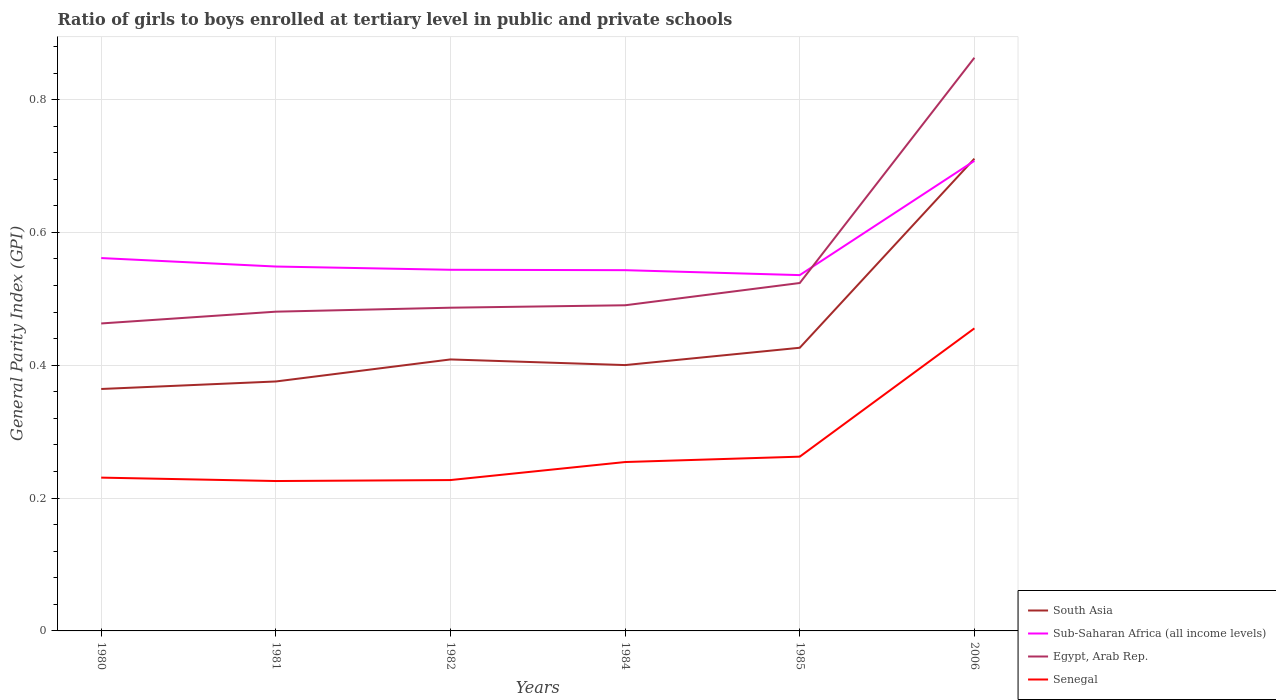Across all years, what is the maximum general parity index in Senegal?
Offer a very short reply. 0.23. In which year was the general parity index in Sub-Saharan Africa (all income levels) maximum?
Provide a succinct answer. 1985. What is the total general parity index in Egypt, Arab Rep. in the graph?
Ensure brevity in your answer.  -0.03. What is the difference between the highest and the second highest general parity index in Egypt, Arab Rep.?
Your answer should be very brief. 0.4. What is the difference between the highest and the lowest general parity index in South Asia?
Ensure brevity in your answer.  1. How many lines are there?
Provide a succinct answer. 4. How many years are there in the graph?
Your answer should be very brief. 6. Does the graph contain any zero values?
Ensure brevity in your answer.  No. Where does the legend appear in the graph?
Your response must be concise. Bottom right. How are the legend labels stacked?
Offer a terse response. Vertical. What is the title of the graph?
Make the answer very short. Ratio of girls to boys enrolled at tertiary level in public and private schools. Does "Vanuatu" appear as one of the legend labels in the graph?
Make the answer very short. No. What is the label or title of the X-axis?
Your response must be concise. Years. What is the label or title of the Y-axis?
Provide a succinct answer. General Parity Index (GPI). What is the General Parity Index (GPI) of South Asia in 1980?
Ensure brevity in your answer.  0.36. What is the General Parity Index (GPI) of Sub-Saharan Africa (all income levels) in 1980?
Offer a terse response. 0.56. What is the General Parity Index (GPI) in Egypt, Arab Rep. in 1980?
Provide a short and direct response. 0.46. What is the General Parity Index (GPI) in Senegal in 1980?
Your answer should be very brief. 0.23. What is the General Parity Index (GPI) in South Asia in 1981?
Make the answer very short. 0.38. What is the General Parity Index (GPI) of Sub-Saharan Africa (all income levels) in 1981?
Keep it short and to the point. 0.55. What is the General Parity Index (GPI) in Egypt, Arab Rep. in 1981?
Provide a short and direct response. 0.48. What is the General Parity Index (GPI) of Senegal in 1981?
Provide a succinct answer. 0.23. What is the General Parity Index (GPI) in South Asia in 1982?
Give a very brief answer. 0.41. What is the General Parity Index (GPI) of Sub-Saharan Africa (all income levels) in 1982?
Ensure brevity in your answer.  0.54. What is the General Parity Index (GPI) of Egypt, Arab Rep. in 1982?
Your answer should be very brief. 0.49. What is the General Parity Index (GPI) of Senegal in 1982?
Give a very brief answer. 0.23. What is the General Parity Index (GPI) of South Asia in 1984?
Make the answer very short. 0.4. What is the General Parity Index (GPI) in Sub-Saharan Africa (all income levels) in 1984?
Offer a terse response. 0.54. What is the General Parity Index (GPI) of Egypt, Arab Rep. in 1984?
Keep it short and to the point. 0.49. What is the General Parity Index (GPI) of Senegal in 1984?
Provide a short and direct response. 0.25. What is the General Parity Index (GPI) of South Asia in 1985?
Provide a short and direct response. 0.43. What is the General Parity Index (GPI) in Sub-Saharan Africa (all income levels) in 1985?
Your answer should be compact. 0.54. What is the General Parity Index (GPI) in Egypt, Arab Rep. in 1985?
Make the answer very short. 0.52. What is the General Parity Index (GPI) of Senegal in 1985?
Your answer should be compact. 0.26. What is the General Parity Index (GPI) of South Asia in 2006?
Offer a very short reply. 0.71. What is the General Parity Index (GPI) in Sub-Saharan Africa (all income levels) in 2006?
Your answer should be compact. 0.71. What is the General Parity Index (GPI) of Egypt, Arab Rep. in 2006?
Your answer should be compact. 0.86. What is the General Parity Index (GPI) of Senegal in 2006?
Offer a terse response. 0.46. Across all years, what is the maximum General Parity Index (GPI) in South Asia?
Make the answer very short. 0.71. Across all years, what is the maximum General Parity Index (GPI) of Sub-Saharan Africa (all income levels)?
Your answer should be compact. 0.71. Across all years, what is the maximum General Parity Index (GPI) in Egypt, Arab Rep.?
Provide a succinct answer. 0.86. Across all years, what is the maximum General Parity Index (GPI) in Senegal?
Your answer should be very brief. 0.46. Across all years, what is the minimum General Parity Index (GPI) in South Asia?
Keep it short and to the point. 0.36. Across all years, what is the minimum General Parity Index (GPI) of Sub-Saharan Africa (all income levels)?
Offer a very short reply. 0.54. Across all years, what is the minimum General Parity Index (GPI) of Egypt, Arab Rep.?
Provide a short and direct response. 0.46. Across all years, what is the minimum General Parity Index (GPI) of Senegal?
Make the answer very short. 0.23. What is the total General Parity Index (GPI) in South Asia in the graph?
Give a very brief answer. 2.69. What is the total General Parity Index (GPI) of Sub-Saharan Africa (all income levels) in the graph?
Your response must be concise. 3.44. What is the total General Parity Index (GPI) of Egypt, Arab Rep. in the graph?
Give a very brief answer. 3.31. What is the total General Parity Index (GPI) of Senegal in the graph?
Make the answer very short. 1.66. What is the difference between the General Parity Index (GPI) of South Asia in 1980 and that in 1981?
Your answer should be compact. -0.01. What is the difference between the General Parity Index (GPI) of Sub-Saharan Africa (all income levels) in 1980 and that in 1981?
Your answer should be compact. 0.01. What is the difference between the General Parity Index (GPI) in Egypt, Arab Rep. in 1980 and that in 1981?
Offer a very short reply. -0.02. What is the difference between the General Parity Index (GPI) of Senegal in 1980 and that in 1981?
Your answer should be very brief. 0.01. What is the difference between the General Parity Index (GPI) in South Asia in 1980 and that in 1982?
Keep it short and to the point. -0.04. What is the difference between the General Parity Index (GPI) of Sub-Saharan Africa (all income levels) in 1980 and that in 1982?
Provide a short and direct response. 0.02. What is the difference between the General Parity Index (GPI) in Egypt, Arab Rep. in 1980 and that in 1982?
Offer a terse response. -0.02. What is the difference between the General Parity Index (GPI) in Senegal in 1980 and that in 1982?
Your answer should be very brief. 0. What is the difference between the General Parity Index (GPI) in South Asia in 1980 and that in 1984?
Give a very brief answer. -0.04. What is the difference between the General Parity Index (GPI) in Sub-Saharan Africa (all income levels) in 1980 and that in 1984?
Keep it short and to the point. 0.02. What is the difference between the General Parity Index (GPI) of Egypt, Arab Rep. in 1980 and that in 1984?
Offer a very short reply. -0.03. What is the difference between the General Parity Index (GPI) of Senegal in 1980 and that in 1984?
Your answer should be compact. -0.02. What is the difference between the General Parity Index (GPI) in South Asia in 1980 and that in 1985?
Ensure brevity in your answer.  -0.06. What is the difference between the General Parity Index (GPI) in Sub-Saharan Africa (all income levels) in 1980 and that in 1985?
Offer a very short reply. 0.03. What is the difference between the General Parity Index (GPI) of Egypt, Arab Rep. in 1980 and that in 1985?
Offer a very short reply. -0.06. What is the difference between the General Parity Index (GPI) of Senegal in 1980 and that in 1985?
Offer a terse response. -0.03. What is the difference between the General Parity Index (GPI) of South Asia in 1980 and that in 2006?
Provide a succinct answer. -0.35. What is the difference between the General Parity Index (GPI) of Sub-Saharan Africa (all income levels) in 1980 and that in 2006?
Offer a terse response. -0.15. What is the difference between the General Parity Index (GPI) in Egypt, Arab Rep. in 1980 and that in 2006?
Your response must be concise. -0.4. What is the difference between the General Parity Index (GPI) in Senegal in 1980 and that in 2006?
Give a very brief answer. -0.22. What is the difference between the General Parity Index (GPI) of South Asia in 1981 and that in 1982?
Your response must be concise. -0.03. What is the difference between the General Parity Index (GPI) in Sub-Saharan Africa (all income levels) in 1981 and that in 1982?
Provide a short and direct response. 0. What is the difference between the General Parity Index (GPI) of Egypt, Arab Rep. in 1981 and that in 1982?
Offer a very short reply. -0.01. What is the difference between the General Parity Index (GPI) in Senegal in 1981 and that in 1982?
Your response must be concise. -0. What is the difference between the General Parity Index (GPI) of South Asia in 1981 and that in 1984?
Offer a very short reply. -0.02. What is the difference between the General Parity Index (GPI) of Sub-Saharan Africa (all income levels) in 1981 and that in 1984?
Keep it short and to the point. 0.01. What is the difference between the General Parity Index (GPI) of Egypt, Arab Rep. in 1981 and that in 1984?
Make the answer very short. -0.01. What is the difference between the General Parity Index (GPI) in Senegal in 1981 and that in 1984?
Offer a terse response. -0.03. What is the difference between the General Parity Index (GPI) of South Asia in 1981 and that in 1985?
Offer a very short reply. -0.05. What is the difference between the General Parity Index (GPI) in Sub-Saharan Africa (all income levels) in 1981 and that in 1985?
Make the answer very short. 0.01. What is the difference between the General Parity Index (GPI) of Egypt, Arab Rep. in 1981 and that in 1985?
Give a very brief answer. -0.04. What is the difference between the General Parity Index (GPI) of Senegal in 1981 and that in 1985?
Make the answer very short. -0.04. What is the difference between the General Parity Index (GPI) in South Asia in 1981 and that in 2006?
Your answer should be compact. -0.34. What is the difference between the General Parity Index (GPI) in Sub-Saharan Africa (all income levels) in 1981 and that in 2006?
Ensure brevity in your answer.  -0.16. What is the difference between the General Parity Index (GPI) of Egypt, Arab Rep. in 1981 and that in 2006?
Make the answer very short. -0.38. What is the difference between the General Parity Index (GPI) of Senegal in 1981 and that in 2006?
Offer a terse response. -0.23. What is the difference between the General Parity Index (GPI) in South Asia in 1982 and that in 1984?
Ensure brevity in your answer.  0.01. What is the difference between the General Parity Index (GPI) in Sub-Saharan Africa (all income levels) in 1982 and that in 1984?
Offer a terse response. 0. What is the difference between the General Parity Index (GPI) of Egypt, Arab Rep. in 1982 and that in 1984?
Provide a short and direct response. -0. What is the difference between the General Parity Index (GPI) of Senegal in 1982 and that in 1984?
Offer a very short reply. -0.03. What is the difference between the General Parity Index (GPI) of South Asia in 1982 and that in 1985?
Offer a terse response. -0.02. What is the difference between the General Parity Index (GPI) of Sub-Saharan Africa (all income levels) in 1982 and that in 1985?
Offer a very short reply. 0.01. What is the difference between the General Parity Index (GPI) of Egypt, Arab Rep. in 1982 and that in 1985?
Make the answer very short. -0.04. What is the difference between the General Parity Index (GPI) in Senegal in 1982 and that in 1985?
Offer a terse response. -0.04. What is the difference between the General Parity Index (GPI) in South Asia in 1982 and that in 2006?
Provide a succinct answer. -0.3. What is the difference between the General Parity Index (GPI) of Sub-Saharan Africa (all income levels) in 1982 and that in 2006?
Provide a short and direct response. -0.16. What is the difference between the General Parity Index (GPI) of Egypt, Arab Rep. in 1982 and that in 2006?
Your answer should be very brief. -0.38. What is the difference between the General Parity Index (GPI) in Senegal in 1982 and that in 2006?
Your response must be concise. -0.23. What is the difference between the General Parity Index (GPI) in South Asia in 1984 and that in 1985?
Make the answer very short. -0.03. What is the difference between the General Parity Index (GPI) in Sub-Saharan Africa (all income levels) in 1984 and that in 1985?
Make the answer very short. 0.01. What is the difference between the General Parity Index (GPI) of Egypt, Arab Rep. in 1984 and that in 1985?
Offer a terse response. -0.03. What is the difference between the General Parity Index (GPI) in Senegal in 1984 and that in 1985?
Provide a succinct answer. -0.01. What is the difference between the General Parity Index (GPI) in South Asia in 1984 and that in 2006?
Your answer should be very brief. -0.31. What is the difference between the General Parity Index (GPI) in Sub-Saharan Africa (all income levels) in 1984 and that in 2006?
Ensure brevity in your answer.  -0.16. What is the difference between the General Parity Index (GPI) in Egypt, Arab Rep. in 1984 and that in 2006?
Keep it short and to the point. -0.37. What is the difference between the General Parity Index (GPI) in Senegal in 1984 and that in 2006?
Provide a succinct answer. -0.2. What is the difference between the General Parity Index (GPI) in South Asia in 1985 and that in 2006?
Ensure brevity in your answer.  -0.28. What is the difference between the General Parity Index (GPI) in Sub-Saharan Africa (all income levels) in 1985 and that in 2006?
Keep it short and to the point. -0.17. What is the difference between the General Parity Index (GPI) in Egypt, Arab Rep. in 1985 and that in 2006?
Keep it short and to the point. -0.34. What is the difference between the General Parity Index (GPI) in Senegal in 1985 and that in 2006?
Provide a succinct answer. -0.19. What is the difference between the General Parity Index (GPI) in South Asia in 1980 and the General Parity Index (GPI) in Sub-Saharan Africa (all income levels) in 1981?
Offer a very short reply. -0.18. What is the difference between the General Parity Index (GPI) of South Asia in 1980 and the General Parity Index (GPI) of Egypt, Arab Rep. in 1981?
Keep it short and to the point. -0.12. What is the difference between the General Parity Index (GPI) in South Asia in 1980 and the General Parity Index (GPI) in Senegal in 1981?
Ensure brevity in your answer.  0.14. What is the difference between the General Parity Index (GPI) in Sub-Saharan Africa (all income levels) in 1980 and the General Parity Index (GPI) in Egypt, Arab Rep. in 1981?
Offer a terse response. 0.08. What is the difference between the General Parity Index (GPI) of Sub-Saharan Africa (all income levels) in 1980 and the General Parity Index (GPI) of Senegal in 1981?
Offer a terse response. 0.34. What is the difference between the General Parity Index (GPI) in Egypt, Arab Rep. in 1980 and the General Parity Index (GPI) in Senegal in 1981?
Your answer should be compact. 0.24. What is the difference between the General Parity Index (GPI) of South Asia in 1980 and the General Parity Index (GPI) of Sub-Saharan Africa (all income levels) in 1982?
Your answer should be very brief. -0.18. What is the difference between the General Parity Index (GPI) of South Asia in 1980 and the General Parity Index (GPI) of Egypt, Arab Rep. in 1982?
Provide a succinct answer. -0.12. What is the difference between the General Parity Index (GPI) in South Asia in 1980 and the General Parity Index (GPI) in Senegal in 1982?
Give a very brief answer. 0.14. What is the difference between the General Parity Index (GPI) of Sub-Saharan Africa (all income levels) in 1980 and the General Parity Index (GPI) of Egypt, Arab Rep. in 1982?
Offer a terse response. 0.07. What is the difference between the General Parity Index (GPI) of Sub-Saharan Africa (all income levels) in 1980 and the General Parity Index (GPI) of Senegal in 1982?
Provide a succinct answer. 0.33. What is the difference between the General Parity Index (GPI) in Egypt, Arab Rep. in 1980 and the General Parity Index (GPI) in Senegal in 1982?
Offer a terse response. 0.24. What is the difference between the General Parity Index (GPI) of South Asia in 1980 and the General Parity Index (GPI) of Sub-Saharan Africa (all income levels) in 1984?
Provide a short and direct response. -0.18. What is the difference between the General Parity Index (GPI) in South Asia in 1980 and the General Parity Index (GPI) in Egypt, Arab Rep. in 1984?
Your response must be concise. -0.13. What is the difference between the General Parity Index (GPI) in South Asia in 1980 and the General Parity Index (GPI) in Senegal in 1984?
Your answer should be very brief. 0.11. What is the difference between the General Parity Index (GPI) in Sub-Saharan Africa (all income levels) in 1980 and the General Parity Index (GPI) in Egypt, Arab Rep. in 1984?
Your response must be concise. 0.07. What is the difference between the General Parity Index (GPI) in Sub-Saharan Africa (all income levels) in 1980 and the General Parity Index (GPI) in Senegal in 1984?
Your response must be concise. 0.31. What is the difference between the General Parity Index (GPI) of Egypt, Arab Rep. in 1980 and the General Parity Index (GPI) of Senegal in 1984?
Your answer should be very brief. 0.21. What is the difference between the General Parity Index (GPI) of South Asia in 1980 and the General Parity Index (GPI) of Sub-Saharan Africa (all income levels) in 1985?
Make the answer very short. -0.17. What is the difference between the General Parity Index (GPI) of South Asia in 1980 and the General Parity Index (GPI) of Egypt, Arab Rep. in 1985?
Your answer should be very brief. -0.16. What is the difference between the General Parity Index (GPI) of South Asia in 1980 and the General Parity Index (GPI) of Senegal in 1985?
Keep it short and to the point. 0.1. What is the difference between the General Parity Index (GPI) of Sub-Saharan Africa (all income levels) in 1980 and the General Parity Index (GPI) of Egypt, Arab Rep. in 1985?
Offer a terse response. 0.04. What is the difference between the General Parity Index (GPI) of Sub-Saharan Africa (all income levels) in 1980 and the General Parity Index (GPI) of Senegal in 1985?
Give a very brief answer. 0.3. What is the difference between the General Parity Index (GPI) in Egypt, Arab Rep. in 1980 and the General Parity Index (GPI) in Senegal in 1985?
Give a very brief answer. 0.2. What is the difference between the General Parity Index (GPI) of South Asia in 1980 and the General Parity Index (GPI) of Sub-Saharan Africa (all income levels) in 2006?
Provide a succinct answer. -0.34. What is the difference between the General Parity Index (GPI) of South Asia in 1980 and the General Parity Index (GPI) of Egypt, Arab Rep. in 2006?
Your answer should be very brief. -0.5. What is the difference between the General Parity Index (GPI) in South Asia in 1980 and the General Parity Index (GPI) in Senegal in 2006?
Your answer should be very brief. -0.09. What is the difference between the General Parity Index (GPI) in Sub-Saharan Africa (all income levels) in 1980 and the General Parity Index (GPI) in Egypt, Arab Rep. in 2006?
Keep it short and to the point. -0.3. What is the difference between the General Parity Index (GPI) of Sub-Saharan Africa (all income levels) in 1980 and the General Parity Index (GPI) of Senegal in 2006?
Offer a terse response. 0.11. What is the difference between the General Parity Index (GPI) of Egypt, Arab Rep. in 1980 and the General Parity Index (GPI) of Senegal in 2006?
Your answer should be very brief. 0.01. What is the difference between the General Parity Index (GPI) in South Asia in 1981 and the General Parity Index (GPI) in Sub-Saharan Africa (all income levels) in 1982?
Your answer should be compact. -0.17. What is the difference between the General Parity Index (GPI) in South Asia in 1981 and the General Parity Index (GPI) in Egypt, Arab Rep. in 1982?
Your answer should be very brief. -0.11. What is the difference between the General Parity Index (GPI) of South Asia in 1981 and the General Parity Index (GPI) of Senegal in 1982?
Your response must be concise. 0.15. What is the difference between the General Parity Index (GPI) in Sub-Saharan Africa (all income levels) in 1981 and the General Parity Index (GPI) in Egypt, Arab Rep. in 1982?
Ensure brevity in your answer.  0.06. What is the difference between the General Parity Index (GPI) in Sub-Saharan Africa (all income levels) in 1981 and the General Parity Index (GPI) in Senegal in 1982?
Your answer should be very brief. 0.32. What is the difference between the General Parity Index (GPI) of Egypt, Arab Rep. in 1981 and the General Parity Index (GPI) of Senegal in 1982?
Ensure brevity in your answer.  0.25. What is the difference between the General Parity Index (GPI) in South Asia in 1981 and the General Parity Index (GPI) in Sub-Saharan Africa (all income levels) in 1984?
Provide a short and direct response. -0.17. What is the difference between the General Parity Index (GPI) of South Asia in 1981 and the General Parity Index (GPI) of Egypt, Arab Rep. in 1984?
Make the answer very short. -0.11. What is the difference between the General Parity Index (GPI) in South Asia in 1981 and the General Parity Index (GPI) in Senegal in 1984?
Offer a very short reply. 0.12. What is the difference between the General Parity Index (GPI) in Sub-Saharan Africa (all income levels) in 1981 and the General Parity Index (GPI) in Egypt, Arab Rep. in 1984?
Keep it short and to the point. 0.06. What is the difference between the General Parity Index (GPI) of Sub-Saharan Africa (all income levels) in 1981 and the General Parity Index (GPI) of Senegal in 1984?
Offer a very short reply. 0.29. What is the difference between the General Parity Index (GPI) in Egypt, Arab Rep. in 1981 and the General Parity Index (GPI) in Senegal in 1984?
Provide a succinct answer. 0.23. What is the difference between the General Parity Index (GPI) of South Asia in 1981 and the General Parity Index (GPI) of Sub-Saharan Africa (all income levels) in 1985?
Your answer should be very brief. -0.16. What is the difference between the General Parity Index (GPI) in South Asia in 1981 and the General Parity Index (GPI) in Egypt, Arab Rep. in 1985?
Make the answer very short. -0.15. What is the difference between the General Parity Index (GPI) of South Asia in 1981 and the General Parity Index (GPI) of Senegal in 1985?
Keep it short and to the point. 0.11. What is the difference between the General Parity Index (GPI) of Sub-Saharan Africa (all income levels) in 1981 and the General Parity Index (GPI) of Egypt, Arab Rep. in 1985?
Offer a terse response. 0.02. What is the difference between the General Parity Index (GPI) in Sub-Saharan Africa (all income levels) in 1981 and the General Parity Index (GPI) in Senegal in 1985?
Keep it short and to the point. 0.29. What is the difference between the General Parity Index (GPI) of Egypt, Arab Rep. in 1981 and the General Parity Index (GPI) of Senegal in 1985?
Provide a succinct answer. 0.22. What is the difference between the General Parity Index (GPI) of South Asia in 1981 and the General Parity Index (GPI) of Sub-Saharan Africa (all income levels) in 2006?
Give a very brief answer. -0.33. What is the difference between the General Parity Index (GPI) in South Asia in 1981 and the General Parity Index (GPI) in Egypt, Arab Rep. in 2006?
Give a very brief answer. -0.49. What is the difference between the General Parity Index (GPI) in South Asia in 1981 and the General Parity Index (GPI) in Senegal in 2006?
Make the answer very short. -0.08. What is the difference between the General Parity Index (GPI) of Sub-Saharan Africa (all income levels) in 1981 and the General Parity Index (GPI) of Egypt, Arab Rep. in 2006?
Keep it short and to the point. -0.31. What is the difference between the General Parity Index (GPI) of Sub-Saharan Africa (all income levels) in 1981 and the General Parity Index (GPI) of Senegal in 2006?
Offer a very short reply. 0.09. What is the difference between the General Parity Index (GPI) of Egypt, Arab Rep. in 1981 and the General Parity Index (GPI) of Senegal in 2006?
Give a very brief answer. 0.03. What is the difference between the General Parity Index (GPI) of South Asia in 1982 and the General Parity Index (GPI) of Sub-Saharan Africa (all income levels) in 1984?
Give a very brief answer. -0.13. What is the difference between the General Parity Index (GPI) in South Asia in 1982 and the General Parity Index (GPI) in Egypt, Arab Rep. in 1984?
Your answer should be compact. -0.08. What is the difference between the General Parity Index (GPI) in South Asia in 1982 and the General Parity Index (GPI) in Senegal in 1984?
Provide a short and direct response. 0.15. What is the difference between the General Parity Index (GPI) of Sub-Saharan Africa (all income levels) in 1982 and the General Parity Index (GPI) of Egypt, Arab Rep. in 1984?
Offer a terse response. 0.05. What is the difference between the General Parity Index (GPI) in Sub-Saharan Africa (all income levels) in 1982 and the General Parity Index (GPI) in Senegal in 1984?
Your answer should be very brief. 0.29. What is the difference between the General Parity Index (GPI) in Egypt, Arab Rep. in 1982 and the General Parity Index (GPI) in Senegal in 1984?
Make the answer very short. 0.23. What is the difference between the General Parity Index (GPI) in South Asia in 1982 and the General Parity Index (GPI) in Sub-Saharan Africa (all income levels) in 1985?
Ensure brevity in your answer.  -0.13. What is the difference between the General Parity Index (GPI) in South Asia in 1982 and the General Parity Index (GPI) in Egypt, Arab Rep. in 1985?
Offer a very short reply. -0.12. What is the difference between the General Parity Index (GPI) of South Asia in 1982 and the General Parity Index (GPI) of Senegal in 1985?
Ensure brevity in your answer.  0.15. What is the difference between the General Parity Index (GPI) in Sub-Saharan Africa (all income levels) in 1982 and the General Parity Index (GPI) in Egypt, Arab Rep. in 1985?
Offer a very short reply. 0.02. What is the difference between the General Parity Index (GPI) of Sub-Saharan Africa (all income levels) in 1982 and the General Parity Index (GPI) of Senegal in 1985?
Provide a short and direct response. 0.28. What is the difference between the General Parity Index (GPI) in Egypt, Arab Rep. in 1982 and the General Parity Index (GPI) in Senegal in 1985?
Offer a very short reply. 0.22. What is the difference between the General Parity Index (GPI) of South Asia in 1982 and the General Parity Index (GPI) of Sub-Saharan Africa (all income levels) in 2006?
Provide a succinct answer. -0.3. What is the difference between the General Parity Index (GPI) of South Asia in 1982 and the General Parity Index (GPI) of Egypt, Arab Rep. in 2006?
Your response must be concise. -0.45. What is the difference between the General Parity Index (GPI) of South Asia in 1982 and the General Parity Index (GPI) of Senegal in 2006?
Your answer should be very brief. -0.05. What is the difference between the General Parity Index (GPI) of Sub-Saharan Africa (all income levels) in 1982 and the General Parity Index (GPI) of Egypt, Arab Rep. in 2006?
Offer a very short reply. -0.32. What is the difference between the General Parity Index (GPI) of Sub-Saharan Africa (all income levels) in 1982 and the General Parity Index (GPI) of Senegal in 2006?
Offer a terse response. 0.09. What is the difference between the General Parity Index (GPI) in Egypt, Arab Rep. in 1982 and the General Parity Index (GPI) in Senegal in 2006?
Give a very brief answer. 0.03. What is the difference between the General Parity Index (GPI) in South Asia in 1984 and the General Parity Index (GPI) in Sub-Saharan Africa (all income levels) in 1985?
Offer a very short reply. -0.14. What is the difference between the General Parity Index (GPI) of South Asia in 1984 and the General Parity Index (GPI) of Egypt, Arab Rep. in 1985?
Your answer should be very brief. -0.12. What is the difference between the General Parity Index (GPI) in South Asia in 1984 and the General Parity Index (GPI) in Senegal in 1985?
Your answer should be very brief. 0.14. What is the difference between the General Parity Index (GPI) in Sub-Saharan Africa (all income levels) in 1984 and the General Parity Index (GPI) in Egypt, Arab Rep. in 1985?
Your response must be concise. 0.02. What is the difference between the General Parity Index (GPI) of Sub-Saharan Africa (all income levels) in 1984 and the General Parity Index (GPI) of Senegal in 1985?
Your answer should be compact. 0.28. What is the difference between the General Parity Index (GPI) of Egypt, Arab Rep. in 1984 and the General Parity Index (GPI) of Senegal in 1985?
Keep it short and to the point. 0.23. What is the difference between the General Parity Index (GPI) in South Asia in 1984 and the General Parity Index (GPI) in Sub-Saharan Africa (all income levels) in 2006?
Provide a short and direct response. -0.31. What is the difference between the General Parity Index (GPI) of South Asia in 1984 and the General Parity Index (GPI) of Egypt, Arab Rep. in 2006?
Provide a short and direct response. -0.46. What is the difference between the General Parity Index (GPI) in South Asia in 1984 and the General Parity Index (GPI) in Senegal in 2006?
Your answer should be very brief. -0.06. What is the difference between the General Parity Index (GPI) in Sub-Saharan Africa (all income levels) in 1984 and the General Parity Index (GPI) in Egypt, Arab Rep. in 2006?
Your response must be concise. -0.32. What is the difference between the General Parity Index (GPI) in Sub-Saharan Africa (all income levels) in 1984 and the General Parity Index (GPI) in Senegal in 2006?
Ensure brevity in your answer.  0.09. What is the difference between the General Parity Index (GPI) of Egypt, Arab Rep. in 1984 and the General Parity Index (GPI) of Senegal in 2006?
Offer a very short reply. 0.03. What is the difference between the General Parity Index (GPI) in South Asia in 1985 and the General Parity Index (GPI) in Sub-Saharan Africa (all income levels) in 2006?
Your answer should be compact. -0.28. What is the difference between the General Parity Index (GPI) of South Asia in 1985 and the General Parity Index (GPI) of Egypt, Arab Rep. in 2006?
Make the answer very short. -0.44. What is the difference between the General Parity Index (GPI) of South Asia in 1985 and the General Parity Index (GPI) of Senegal in 2006?
Your answer should be compact. -0.03. What is the difference between the General Parity Index (GPI) in Sub-Saharan Africa (all income levels) in 1985 and the General Parity Index (GPI) in Egypt, Arab Rep. in 2006?
Provide a short and direct response. -0.33. What is the difference between the General Parity Index (GPI) of Sub-Saharan Africa (all income levels) in 1985 and the General Parity Index (GPI) of Senegal in 2006?
Your answer should be very brief. 0.08. What is the difference between the General Parity Index (GPI) in Egypt, Arab Rep. in 1985 and the General Parity Index (GPI) in Senegal in 2006?
Ensure brevity in your answer.  0.07. What is the average General Parity Index (GPI) in South Asia per year?
Ensure brevity in your answer.  0.45. What is the average General Parity Index (GPI) of Sub-Saharan Africa (all income levels) per year?
Your answer should be very brief. 0.57. What is the average General Parity Index (GPI) of Egypt, Arab Rep. per year?
Keep it short and to the point. 0.55. What is the average General Parity Index (GPI) of Senegal per year?
Ensure brevity in your answer.  0.28. In the year 1980, what is the difference between the General Parity Index (GPI) in South Asia and General Parity Index (GPI) in Sub-Saharan Africa (all income levels)?
Give a very brief answer. -0.2. In the year 1980, what is the difference between the General Parity Index (GPI) of South Asia and General Parity Index (GPI) of Egypt, Arab Rep.?
Your answer should be very brief. -0.1. In the year 1980, what is the difference between the General Parity Index (GPI) of South Asia and General Parity Index (GPI) of Senegal?
Offer a terse response. 0.13. In the year 1980, what is the difference between the General Parity Index (GPI) in Sub-Saharan Africa (all income levels) and General Parity Index (GPI) in Egypt, Arab Rep.?
Provide a short and direct response. 0.1. In the year 1980, what is the difference between the General Parity Index (GPI) in Sub-Saharan Africa (all income levels) and General Parity Index (GPI) in Senegal?
Provide a succinct answer. 0.33. In the year 1980, what is the difference between the General Parity Index (GPI) in Egypt, Arab Rep. and General Parity Index (GPI) in Senegal?
Your answer should be compact. 0.23. In the year 1981, what is the difference between the General Parity Index (GPI) of South Asia and General Parity Index (GPI) of Sub-Saharan Africa (all income levels)?
Offer a terse response. -0.17. In the year 1981, what is the difference between the General Parity Index (GPI) in South Asia and General Parity Index (GPI) in Egypt, Arab Rep.?
Give a very brief answer. -0.11. In the year 1981, what is the difference between the General Parity Index (GPI) of South Asia and General Parity Index (GPI) of Senegal?
Give a very brief answer. 0.15. In the year 1981, what is the difference between the General Parity Index (GPI) in Sub-Saharan Africa (all income levels) and General Parity Index (GPI) in Egypt, Arab Rep.?
Keep it short and to the point. 0.07. In the year 1981, what is the difference between the General Parity Index (GPI) in Sub-Saharan Africa (all income levels) and General Parity Index (GPI) in Senegal?
Provide a succinct answer. 0.32. In the year 1981, what is the difference between the General Parity Index (GPI) in Egypt, Arab Rep. and General Parity Index (GPI) in Senegal?
Ensure brevity in your answer.  0.26. In the year 1982, what is the difference between the General Parity Index (GPI) of South Asia and General Parity Index (GPI) of Sub-Saharan Africa (all income levels)?
Your answer should be compact. -0.14. In the year 1982, what is the difference between the General Parity Index (GPI) in South Asia and General Parity Index (GPI) in Egypt, Arab Rep.?
Your answer should be compact. -0.08. In the year 1982, what is the difference between the General Parity Index (GPI) of South Asia and General Parity Index (GPI) of Senegal?
Give a very brief answer. 0.18. In the year 1982, what is the difference between the General Parity Index (GPI) of Sub-Saharan Africa (all income levels) and General Parity Index (GPI) of Egypt, Arab Rep.?
Your response must be concise. 0.06. In the year 1982, what is the difference between the General Parity Index (GPI) in Sub-Saharan Africa (all income levels) and General Parity Index (GPI) in Senegal?
Make the answer very short. 0.32. In the year 1982, what is the difference between the General Parity Index (GPI) in Egypt, Arab Rep. and General Parity Index (GPI) in Senegal?
Your answer should be very brief. 0.26. In the year 1984, what is the difference between the General Parity Index (GPI) of South Asia and General Parity Index (GPI) of Sub-Saharan Africa (all income levels)?
Keep it short and to the point. -0.14. In the year 1984, what is the difference between the General Parity Index (GPI) in South Asia and General Parity Index (GPI) in Egypt, Arab Rep.?
Make the answer very short. -0.09. In the year 1984, what is the difference between the General Parity Index (GPI) of South Asia and General Parity Index (GPI) of Senegal?
Provide a succinct answer. 0.15. In the year 1984, what is the difference between the General Parity Index (GPI) of Sub-Saharan Africa (all income levels) and General Parity Index (GPI) of Egypt, Arab Rep.?
Offer a terse response. 0.05. In the year 1984, what is the difference between the General Parity Index (GPI) of Sub-Saharan Africa (all income levels) and General Parity Index (GPI) of Senegal?
Provide a succinct answer. 0.29. In the year 1984, what is the difference between the General Parity Index (GPI) in Egypt, Arab Rep. and General Parity Index (GPI) in Senegal?
Your answer should be very brief. 0.24. In the year 1985, what is the difference between the General Parity Index (GPI) of South Asia and General Parity Index (GPI) of Sub-Saharan Africa (all income levels)?
Offer a very short reply. -0.11. In the year 1985, what is the difference between the General Parity Index (GPI) in South Asia and General Parity Index (GPI) in Egypt, Arab Rep.?
Keep it short and to the point. -0.1. In the year 1985, what is the difference between the General Parity Index (GPI) of South Asia and General Parity Index (GPI) of Senegal?
Your answer should be compact. 0.16. In the year 1985, what is the difference between the General Parity Index (GPI) in Sub-Saharan Africa (all income levels) and General Parity Index (GPI) in Egypt, Arab Rep.?
Your response must be concise. 0.01. In the year 1985, what is the difference between the General Parity Index (GPI) of Sub-Saharan Africa (all income levels) and General Parity Index (GPI) of Senegal?
Your answer should be compact. 0.27. In the year 1985, what is the difference between the General Parity Index (GPI) of Egypt, Arab Rep. and General Parity Index (GPI) of Senegal?
Provide a short and direct response. 0.26. In the year 2006, what is the difference between the General Parity Index (GPI) of South Asia and General Parity Index (GPI) of Sub-Saharan Africa (all income levels)?
Offer a terse response. 0. In the year 2006, what is the difference between the General Parity Index (GPI) of South Asia and General Parity Index (GPI) of Egypt, Arab Rep.?
Make the answer very short. -0.15. In the year 2006, what is the difference between the General Parity Index (GPI) of South Asia and General Parity Index (GPI) of Senegal?
Your response must be concise. 0.26. In the year 2006, what is the difference between the General Parity Index (GPI) in Sub-Saharan Africa (all income levels) and General Parity Index (GPI) in Egypt, Arab Rep.?
Provide a succinct answer. -0.16. In the year 2006, what is the difference between the General Parity Index (GPI) in Sub-Saharan Africa (all income levels) and General Parity Index (GPI) in Senegal?
Your response must be concise. 0.25. In the year 2006, what is the difference between the General Parity Index (GPI) of Egypt, Arab Rep. and General Parity Index (GPI) of Senegal?
Offer a very short reply. 0.41. What is the ratio of the General Parity Index (GPI) in South Asia in 1980 to that in 1981?
Give a very brief answer. 0.97. What is the ratio of the General Parity Index (GPI) of Sub-Saharan Africa (all income levels) in 1980 to that in 1981?
Your answer should be compact. 1.02. What is the ratio of the General Parity Index (GPI) in Egypt, Arab Rep. in 1980 to that in 1981?
Give a very brief answer. 0.96. What is the ratio of the General Parity Index (GPI) of Senegal in 1980 to that in 1981?
Give a very brief answer. 1.02. What is the ratio of the General Parity Index (GPI) of South Asia in 1980 to that in 1982?
Provide a short and direct response. 0.89. What is the ratio of the General Parity Index (GPI) in Sub-Saharan Africa (all income levels) in 1980 to that in 1982?
Provide a succinct answer. 1.03. What is the ratio of the General Parity Index (GPI) of Egypt, Arab Rep. in 1980 to that in 1982?
Offer a very short reply. 0.95. What is the ratio of the General Parity Index (GPI) of Senegal in 1980 to that in 1982?
Provide a short and direct response. 1.02. What is the ratio of the General Parity Index (GPI) in South Asia in 1980 to that in 1984?
Give a very brief answer. 0.91. What is the ratio of the General Parity Index (GPI) of Sub-Saharan Africa (all income levels) in 1980 to that in 1984?
Your answer should be very brief. 1.03. What is the ratio of the General Parity Index (GPI) in Egypt, Arab Rep. in 1980 to that in 1984?
Your response must be concise. 0.94. What is the ratio of the General Parity Index (GPI) in Senegal in 1980 to that in 1984?
Provide a short and direct response. 0.91. What is the ratio of the General Parity Index (GPI) in South Asia in 1980 to that in 1985?
Your answer should be compact. 0.85. What is the ratio of the General Parity Index (GPI) in Sub-Saharan Africa (all income levels) in 1980 to that in 1985?
Ensure brevity in your answer.  1.05. What is the ratio of the General Parity Index (GPI) in Egypt, Arab Rep. in 1980 to that in 1985?
Give a very brief answer. 0.88. What is the ratio of the General Parity Index (GPI) in Senegal in 1980 to that in 1985?
Your answer should be compact. 0.88. What is the ratio of the General Parity Index (GPI) in South Asia in 1980 to that in 2006?
Ensure brevity in your answer.  0.51. What is the ratio of the General Parity Index (GPI) in Sub-Saharan Africa (all income levels) in 1980 to that in 2006?
Keep it short and to the point. 0.79. What is the ratio of the General Parity Index (GPI) of Egypt, Arab Rep. in 1980 to that in 2006?
Your answer should be compact. 0.54. What is the ratio of the General Parity Index (GPI) in Senegal in 1980 to that in 2006?
Your response must be concise. 0.51. What is the ratio of the General Parity Index (GPI) in South Asia in 1981 to that in 1982?
Keep it short and to the point. 0.92. What is the ratio of the General Parity Index (GPI) of Senegal in 1981 to that in 1982?
Keep it short and to the point. 0.99. What is the ratio of the General Parity Index (GPI) of South Asia in 1981 to that in 1984?
Keep it short and to the point. 0.94. What is the ratio of the General Parity Index (GPI) in Sub-Saharan Africa (all income levels) in 1981 to that in 1984?
Your answer should be compact. 1.01. What is the ratio of the General Parity Index (GPI) in Egypt, Arab Rep. in 1981 to that in 1984?
Offer a terse response. 0.98. What is the ratio of the General Parity Index (GPI) in Senegal in 1981 to that in 1984?
Your response must be concise. 0.89. What is the ratio of the General Parity Index (GPI) of South Asia in 1981 to that in 1985?
Your response must be concise. 0.88. What is the ratio of the General Parity Index (GPI) in Sub-Saharan Africa (all income levels) in 1981 to that in 1985?
Your answer should be compact. 1.02. What is the ratio of the General Parity Index (GPI) in Egypt, Arab Rep. in 1981 to that in 1985?
Provide a short and direct response. 0.92. What is the ratio of the General Parity Index (GPI) in Senegal in 1981 to that in 1985?
Give a very brief answer. 0.86. What is the ratio of the General Parity Index (GPI) of South Asia in 1981 to that in 2006?
Your answer should be compact. 0.53. What is the ratio of the General Parity Index (GPI) of Sub-Saharan Africa (all income levels) in 1981 to that in 2006?
Make the answer very short. 0.78. What is the ratio of the General Parity Index (GPI) of Egypt, Arab Rep. in 1981 to that in 2006?
Your response must be concise. 0.56. What is the ratio of the General Parity Index (GPI) in Senegal in 1981 to that in 2006?
Your response must be concise. 0.5. What is the ratio of the General Parity Index (GPI) of South Asia in 1982 to that in 1984?
Provide a succinct answer. 1.02. What is the ratio of the General Parity Index (GPI) in Sub-Saharan Africa (all income levels) in 1982 to that in 1984?
Your answer should be very brief. 1. What is the ratio of the General Parity Index (GPI) in Senegal in 1982 to that in 1984?
Make the answer very short. 0.89. What is the ratio of the General Parity Index (GPI) in South Asia in 1982 to that in 1985?
Ensure brevity in your answer.  0.96. What is the ratio of the General Parity Index (GPI) of Sub-Saharan Africa (all income levels) in 1982 to that in 1985?
Offer a very short reply. 1.01. What is the ratio of the General Parity Index (GPI) in Egypt, Arab Rep. in 1982 to that in 1985?
Ensure brevity in your answer.  0.93. What is the ratio of the General Parity Index (GPI) in Senegal in 1982 to that in 1985?
Offer a terse response. 0.87. What is the ratio of the General Parity Index (GPI) in South Asia in 1982 to that in 2006?
Give a very brief answer. 0.57. What is the ratio of the General Parity Index (GPI) of Sub-Saharan Africa (all income levels) in 1982 to that in 2006?
Your response must be concise. 0.77. What is the ratio of the General Parity Index (GPI) of Egypt, Arab Rep. in 1982 to that in 2006?
Offer a very short reply. 0.56. What is the ratio of the General Parity Index (GPI) in Senegal in 1982 to that in 2006?
Offer a terse response. 0.5. What is the ratio of the General Parity Index (GPI) of South Asia in 1984 to that in 1985?
Ensure brevity in your answer.  0.94. What is the ratio of the General Parity Index (GPI) of Sub-Saharan Africa (all income levels) in 1984 to that in 1985?
Make the answer very short. 1.01. What is the ratio of the General Parity Index (GPI) in Egypt, Arab Rep. in 1984 to that in 1985?
Your answer should be very brief. 0.94. What is the ratio of the General Parity Index (GPI) of Senegal in 1984 to that in 1985?
Make the answer very short. 0.97. What is the ratio of the General Parity Index (GPI) in South Asia in 1984 to that in 2006?
Your answer should be compact. 0.56. What is the ratio of the General Parity Index (GPI) of Sub-Saharan Africa (all income levels) in 1984 to that in 2006?
Provide a succinct answer. 0.77. What is the ratio of the General Parity Index (GPI) of Egypt, Arab Rep. in 1984 to that in 2006?
Offer a terse response. 0.57. What is the ratio of the General Parity Index (GPI) in Senegal in 1984 to that in 2006?
Your answer should be compact. 0.56. What is the ratio of the General Parity Index (GPI) in South Asia in 1985 to that in 2006?
Offer a very short reply. 0.6. What is the ratio of the General Parity Index (GPI) in Sub-Saharan Africa (all income levels) in 1985 to that in 2006?
Give a very brief answer. 0.76. What is the ratio of the General Parity Index (GPI) of Egypt, Arab Rep. in 1985 to that in 2006?
Make the answer very short. 0.61. What is the ratio of the General Parity Index (GPI) of Senegal in 1985 to that in 2006?
Provide a short and direct response. 0.58. What is the difference between the highest and the second highest General Parity Index (GPI) of South Asia?
Provide a succinct answer. 0.28. What is the difference between the highest and the second highest General Parity Index (GPI) of Sub-Saharan Africa (all income levels)?
Your answer should be very brief. 0.15. What is the difference between the highest and the second highest General Parity Index (GPI) of Egypt, Arab Rep.?
Your response must be concise. 0.34. What is the difference between the highest and the second highest General Parity Index (GPI) of Senegal?
Provide a succinct answer. 0.19. What is the difference between the highest and the lowest General Parity Index (GPI) of South Asia?
Keep it short and to the point. 0.35. What is the difference between the highest and the lowest General Parity Index (GPI) in Sub-Saharan Africa (all income levels)?
Give a very brief answer. 0.17. What is the difference between the highest and the lowest General Parity Index (GPI) of Egypt, Arab Rep.?
Your response must be concise. 0.4. What is the difference between the highest and the lowest General Parity Index (GPI) in Senegal?
Keep it short and to the point. 0.23. 